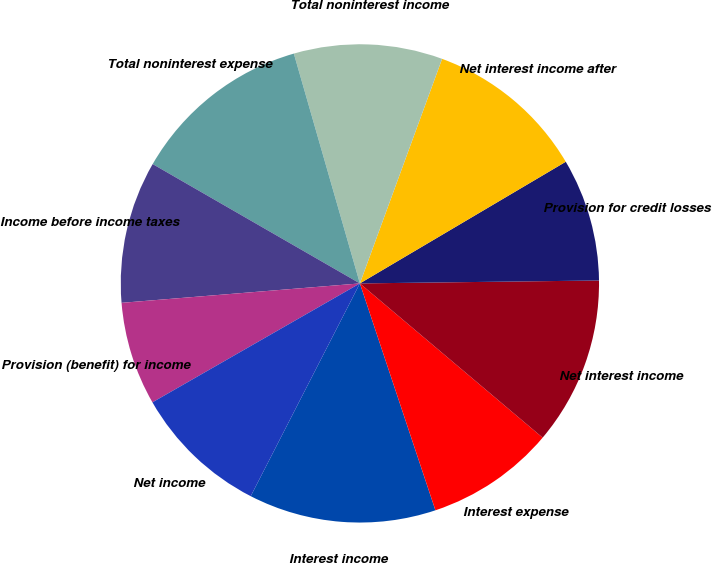Convert chart to OTSL. <chart><loc_0><loc_0><loc_500><loc_500><pie_chart><fcel>Interest income<fcel>Interest expense<fcel>Net interest income<fcel>Provision for credit losses<fcel>Net interest income after<fcel>Total noninterest income<fcel>Total noninterest expense<fcel>Income before income taxes<fcel>Provision (benefit) for income<fcel>Net income<nl><fcel>12.66%<fcel>8.73%<fcel>11.35%<fcel>8.3%<fcel>10.92%<fcel>10.04%<fcel>12.23%<fcel>9.61%<fcel>6.99%<fcel>9.17%<nl></chart> 